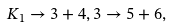Convert formula to latex. <formula><loc_0><loc_0><loc_500><loc_500>K _ { 1 } \rightarrow 3 + 4 , 3 \rightarrow 5 + 6 ,</formula> 